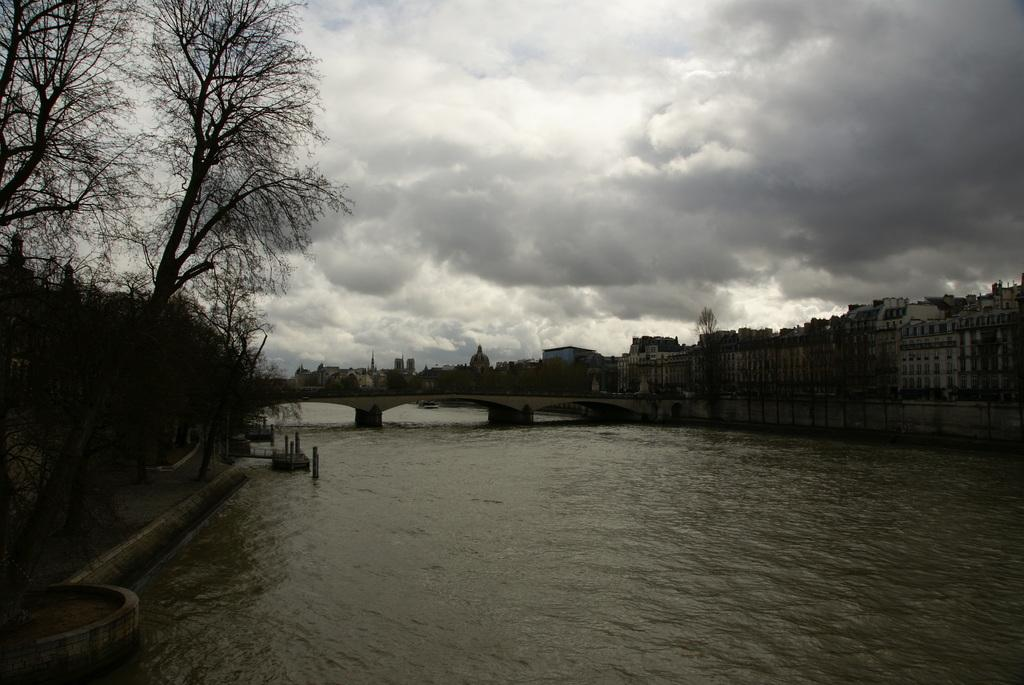What type of structure can be seen in the image? There is a bridge in the image. What natural element is present in the image? There is water visible in the image. What type of vegetation is in the image? There are trees in the image. What type of buildings can be seen in the image? There are buildings with windows in the image. What is visible in the background of the image? The sky is visible in the image. What type of wool is being spun by the wind in the image? There is no wool or wind present in the image. What thoughts are being expressed by the trees in the image? Trees do not have thoughts, and there is no indication of any thoughts being expressed in the image. 